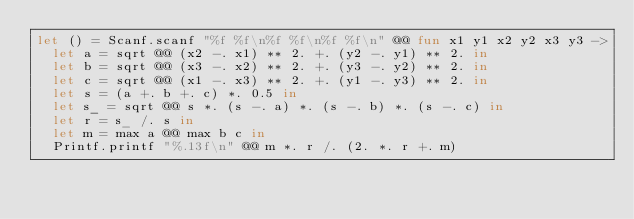Convert code to text. <code><loc_0><loc_0><loc_500><loc_500><_OCaml_>let () = Scanf.scanf "%f %f\n%f %f\n%f %f\n" @@ fun x1 y1 x2 y2 x3 y3 ->
  let a = sqrt @@ (x2 -. x1) ** 2. +. (y2 -. y1) ** 2. in
  let b = sqrt @@ (x3 -. x2) ** 2. +. (y3 -. y2) ** 2. in
  let c = sqrt @@ (x1 -. x3) ** 2. +. (y1 -. y3) ** 2. in
  let s = (a +. b +. c) *. 0.5 in
  let s_ = sqrt @@ s *. (s -. a) *. (s -. b) *. (s -. c) in
  let r = s_ /. s in
  let m = max a @@ max b c in
  Printf.printf "%.13f\n" @@ m *. r /. (2. *. r +. m)
</code> 